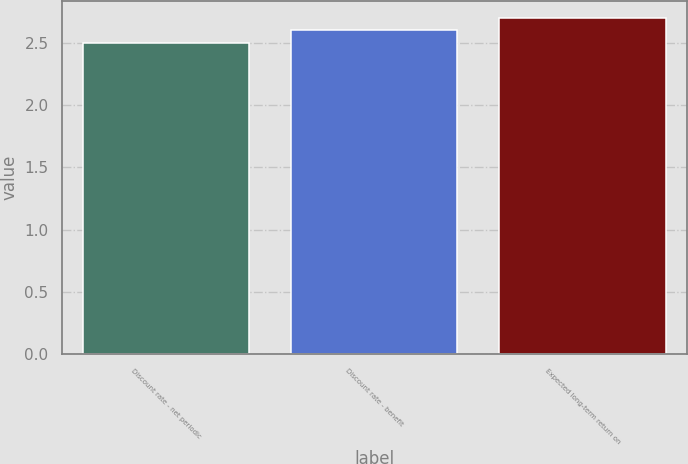Convert chart to OTSL. <chart><loc_0><loc_0><loc_500><loc_500><bar_chart><fcel>Discount rate - net periodic<fcel>Discount rate - benefit<fcel>Expected long-term return on<nl><fcel>2.5<fcel>2.6<fcel>2.7<nl></chart> 